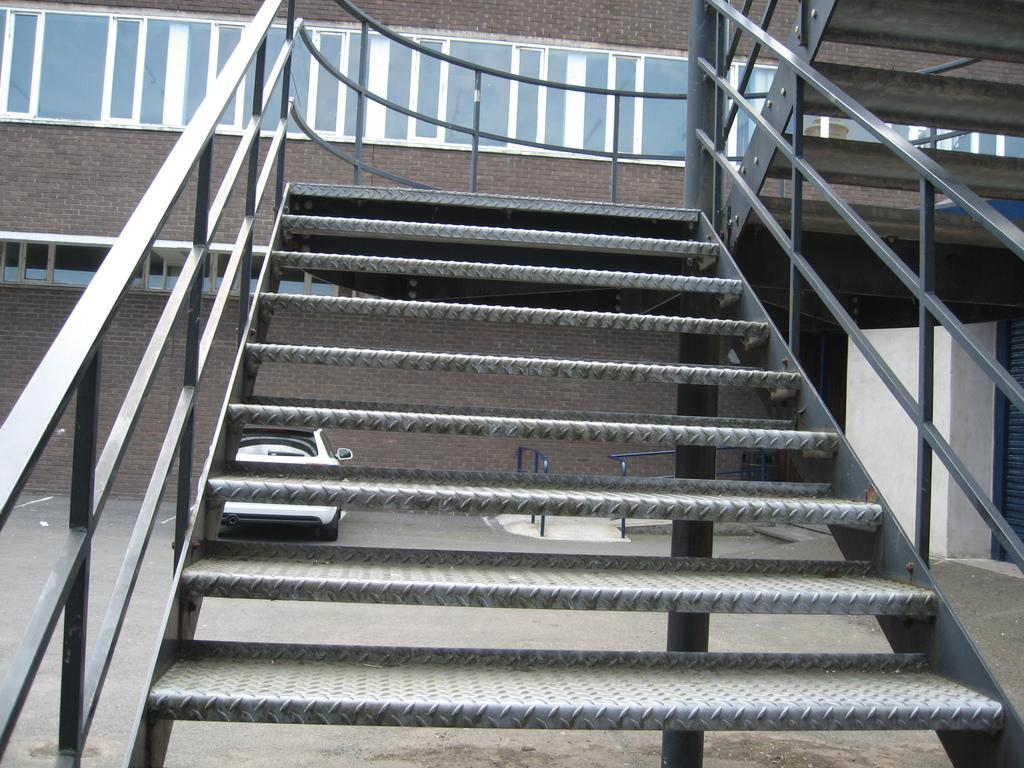What type of structure is present in the image? There is a staircase in the image. What is located on either side of the staircase? There is an iron fence on either side of the staircase. What can be seen in the background of the image? There is a building and a car in the background of the image. How many roots can be seen growing from the sack in the image? There is no sack or roots present in the image. What type of rod is being used to hold up the staircase in the image? There is no rod used to hold up the staircase in the image; it is supported by the iron fence on either side. 